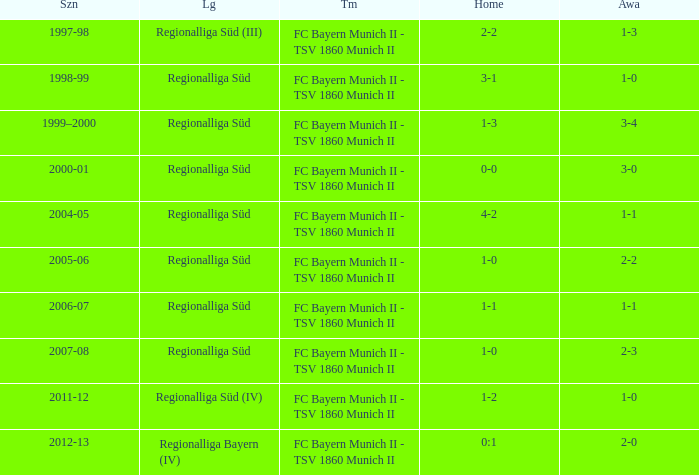What is the home with a 1-1 away in the 2004-05 season? 4-2. 